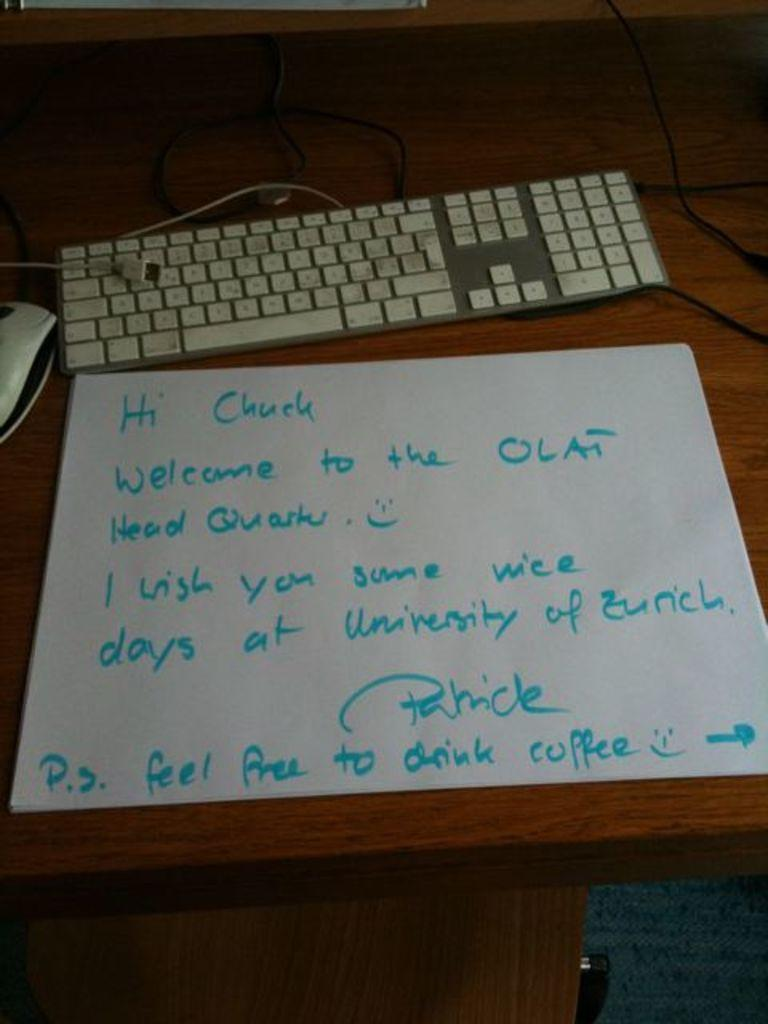<image>
Offer a succinct explanation of the picture presented. a note written in blue marker saying Hi Chuck 